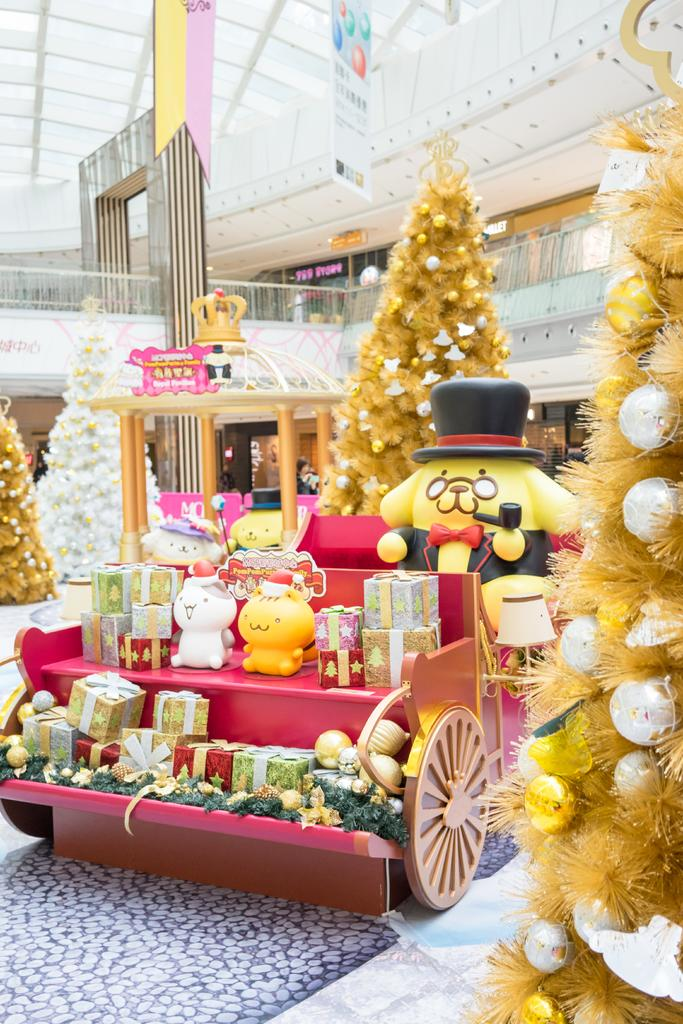What types of items are included in the chart? The chart contains gifts and toys. What holiday-related decoration is depicted on the chart? There are Christmas trees on the chart. What architectural elements can be seen on the chart? There are pillars and a fence on the chart. What is located at the top of the chart? There are hoardings at the top of the chart. What type of disgust can be seen on the faces of the laborers in the image? There are no laborers or expressions of disgust present in the image. 